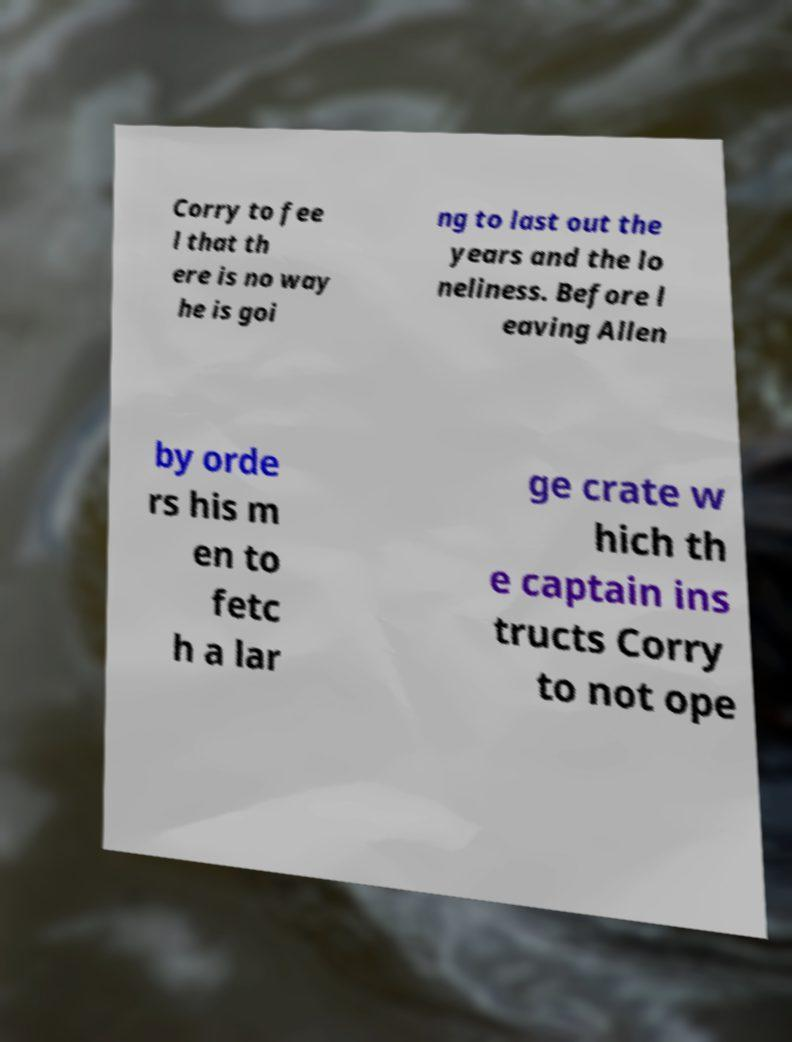For documentation purposes, I need the text within this image transcribed. Could you provide that? Corry to fee l that th ere is no way he is goi ng to last out the years and the lo neliness. Before l eaving Allen by orde rs his m en to fetc h a lar ge crate w hich th e captain ins tructs Corry to not ope 